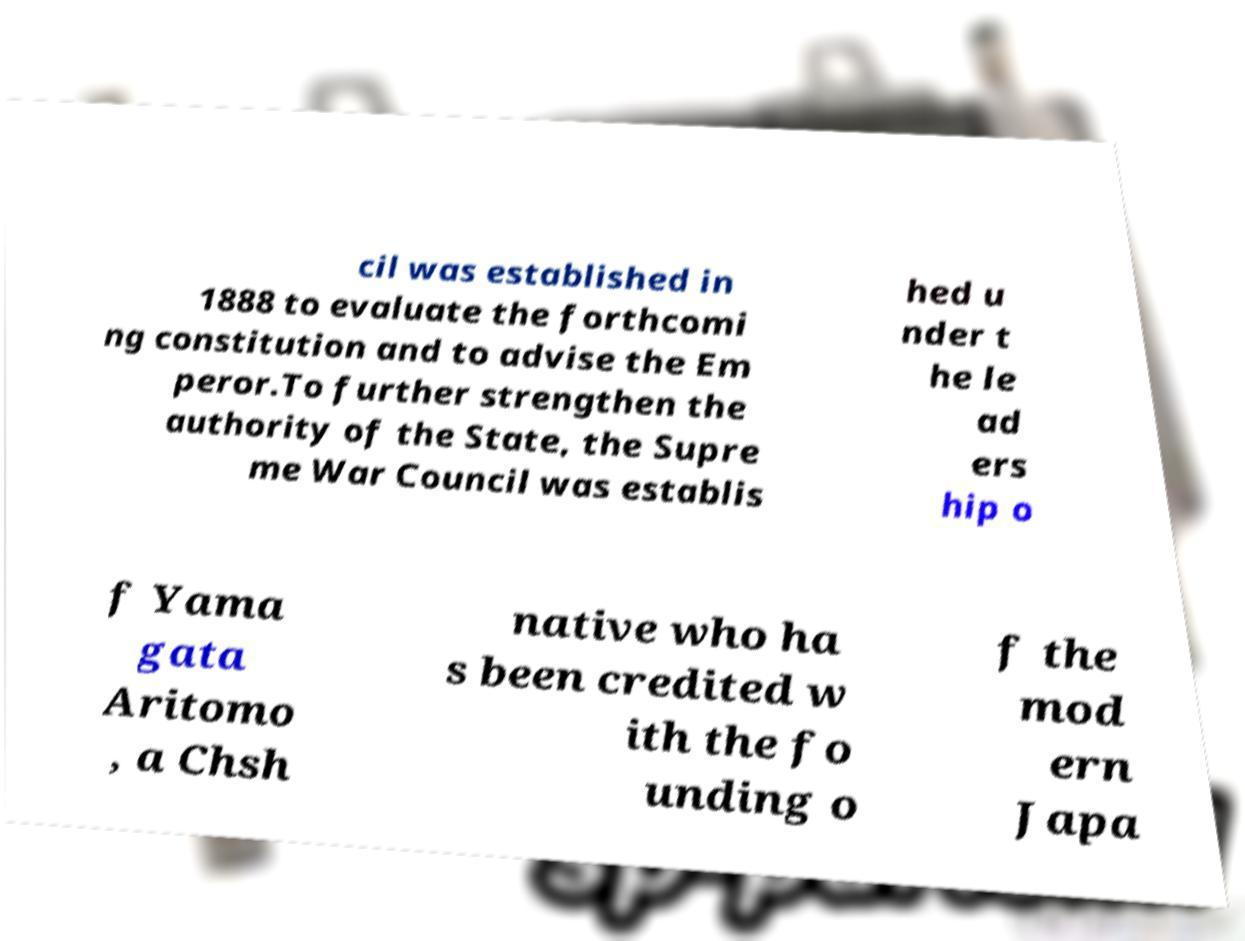Can you read and provide the text displayed in the image?This photo seems to have some interesting text. Can you extract and type it out for me? cil was established in 1888 to evaluate the forthcomi ng constitution and to advise the Em peror.To further strengthen the authority of the State, the Supre me War Council was establis hed u nder t he le ad ers hip o f Yama gata Aritomo , a Chsh native who ha s been credited w ith the fo unding o f the mod ern Japa 